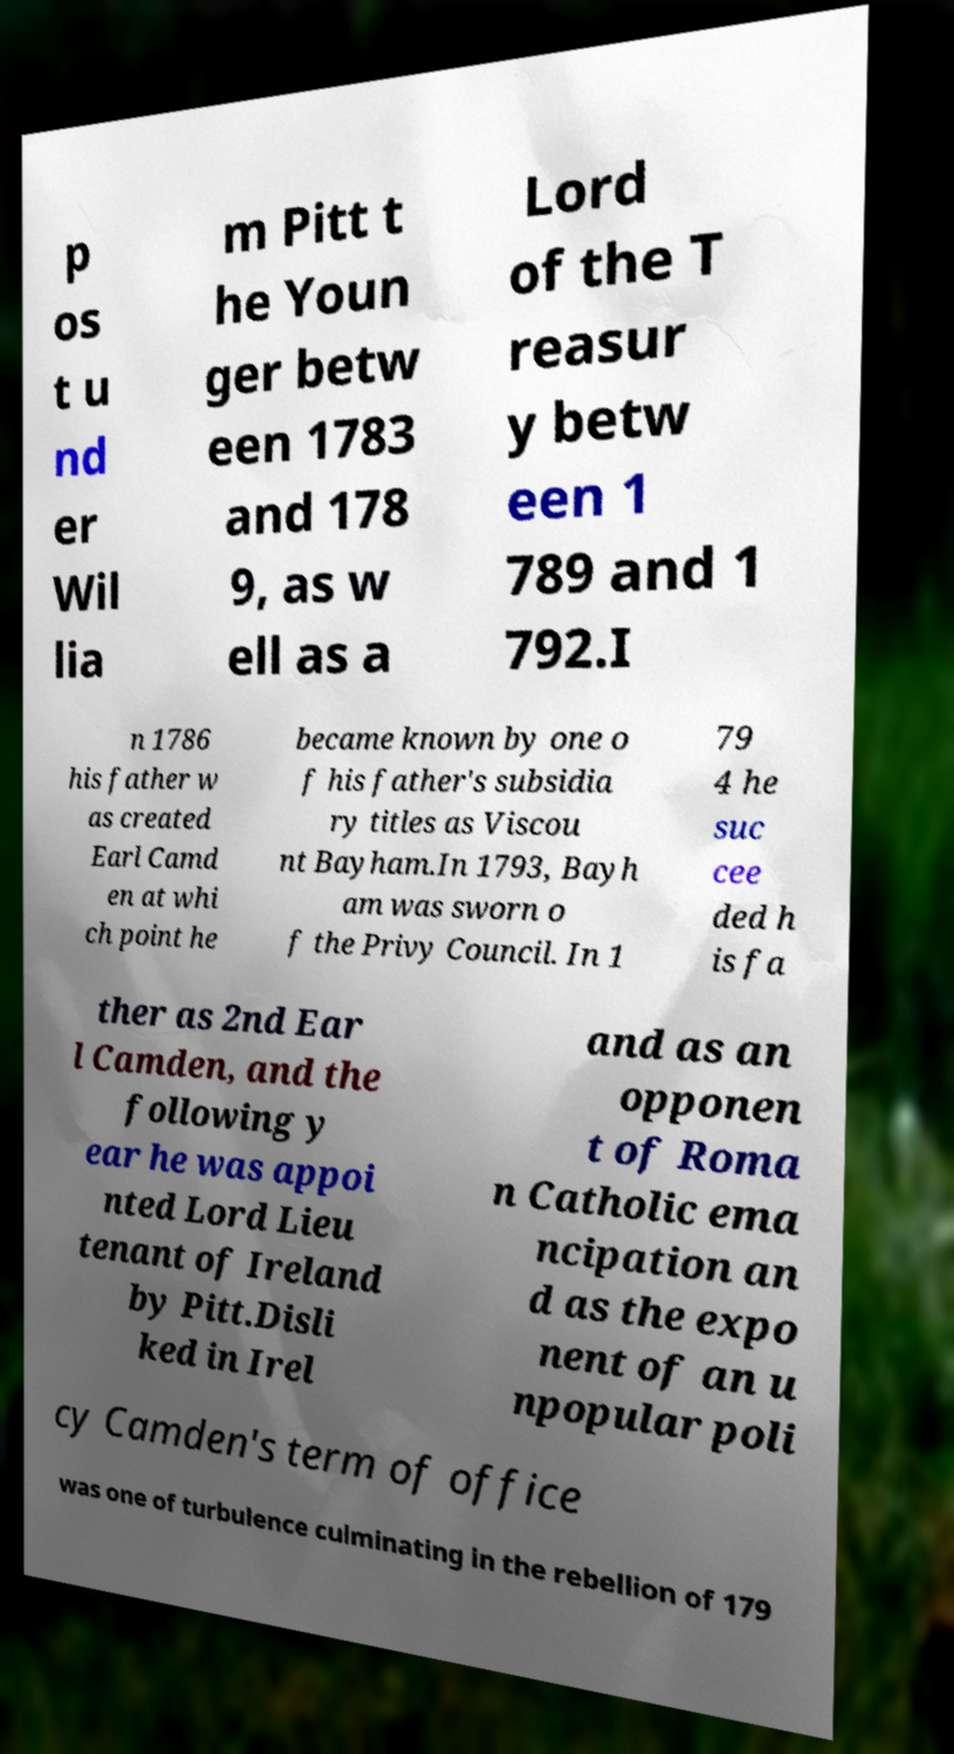There's text embedded in this image that I need extracted. Can you transcribe it verbatim? p os t u nd er Wil lia m Pitt t he Youn ger betw een 1783 and 178 9, as w ell as a Lord of the T reasur y betw een 1 789 and 1 792.I n 1786 his father w as created Earl Camd en at whi ch point he became known by one o f his father's subsidia ry titles as Viscou nt Bayham.In 1793, Bayh am was sworn o f the Privy Council. In 1 79 4 he suc cee ded h is fa ther as 2nd Ear l Camden, and the following y ear he was appoi nted Lord Lieu tenant of Ireland by Pitt.Disli ked in Irel and as an opponen t of Roma n Catholic ema ncipation an d as the expo nent of an u npopular poli cy Camden's term of office was one of turbulence culminating in the rebellion of 179 